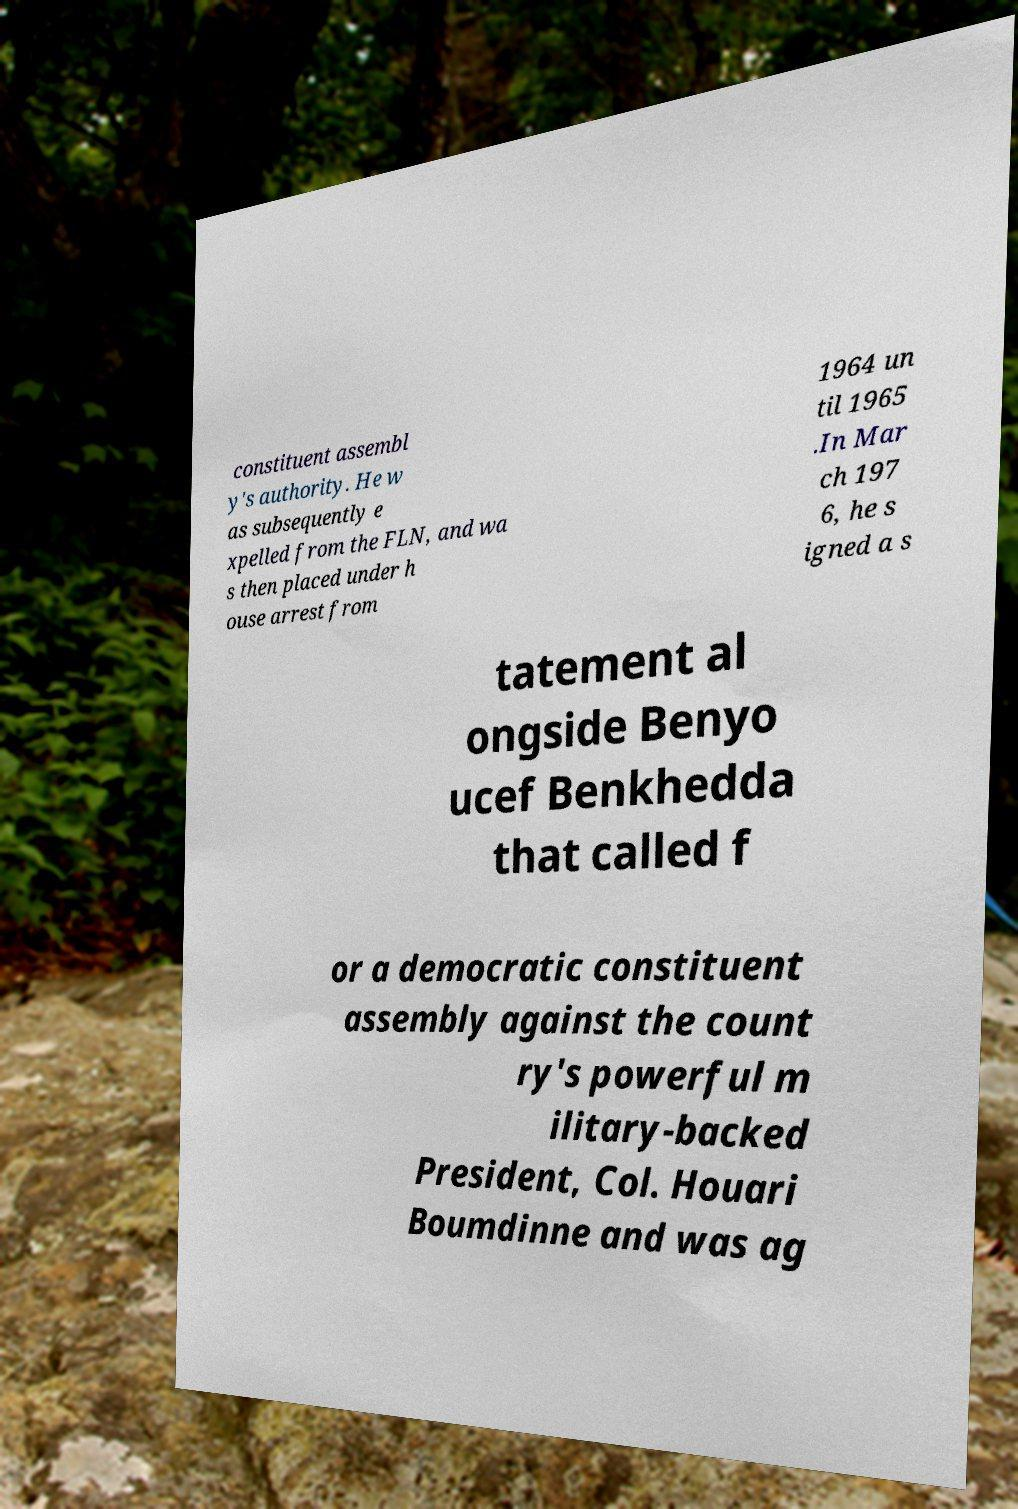Could you extract and type out the text from this image? constituent assembl y's authority. He w as subsequently e xpelled from the FLN, and wa s then placed under h ouse arrest from 1964 un til 1965 .In Mar ch 197 6, he s igned a s tatement al ongside Benyo ucef Benkhedda that called f or a democratic constituent assembly against the count ry's powerful m ilitary-backed President, Col. Houari Boumdinne and was ag 